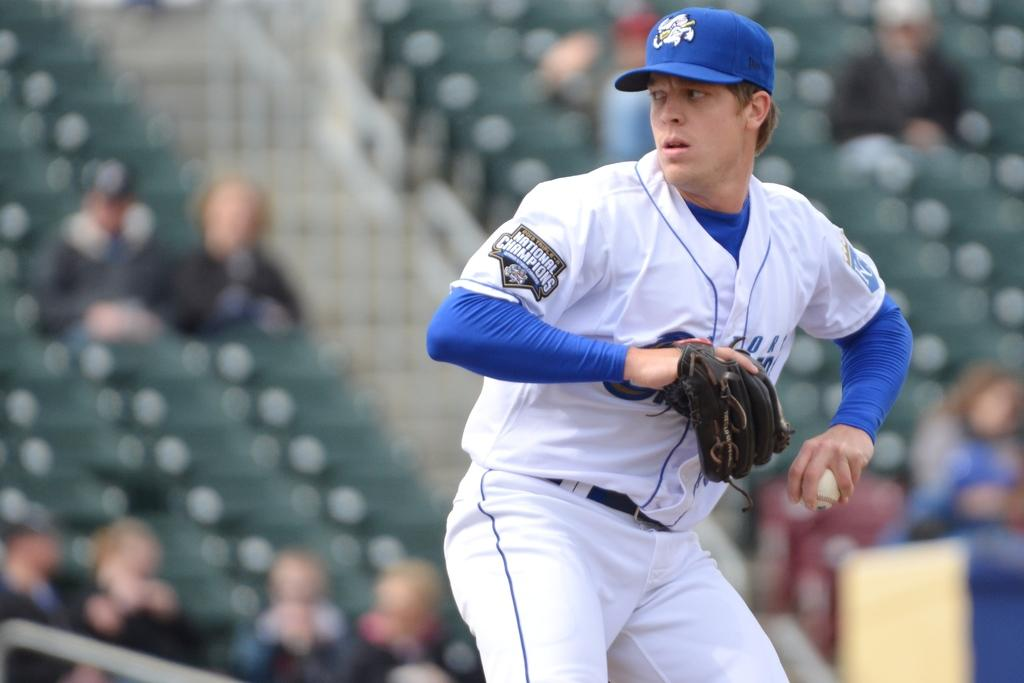<image>
Share a concise interpretation of the image provided. A baseball player's uniform has a patch for the National Championships on the sleeve. 